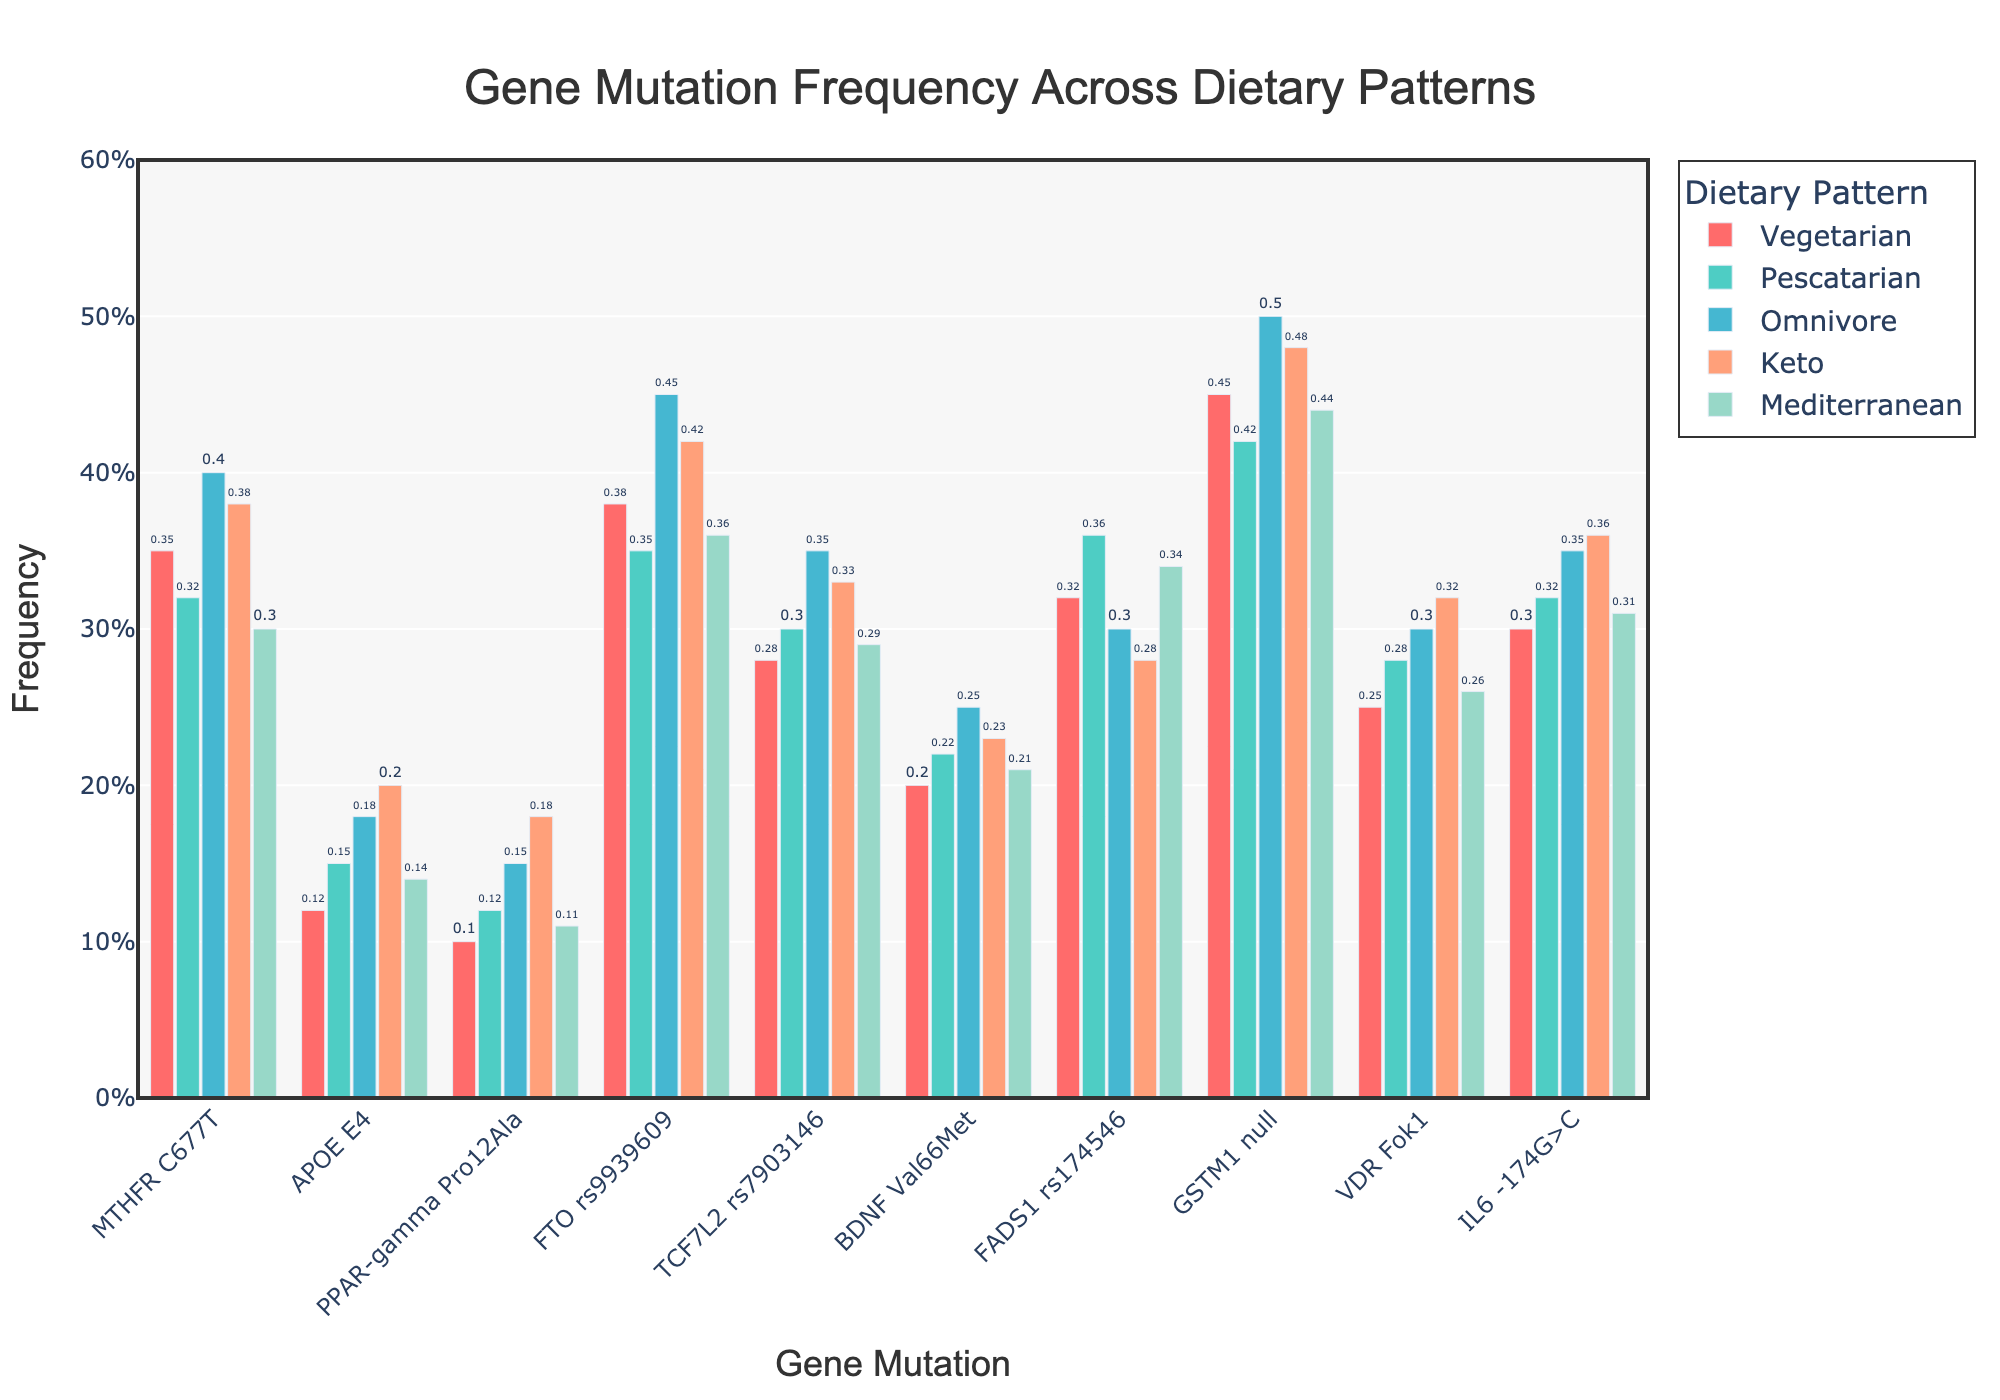Which dietary pattern has the highest frequency of the APOE E4 gene mutation? To determine this, look at the bars associated with the APOE E4 gene mutation across different dietary patterns. The highest bar corresponds to the 'keto' diet.
Answer: Keto What is the difference in frequency of the MTHFR C677T mutation between vegetarians and omnivores? Find the frequency of the MTHFR C677T mutation for both vegetarians (0.35) and omnivores (0.40) from the chart. Subtract the vegetarian frequency from the omnivore frequency to get the difference: 0.40 - 0.35 = 0.05.
Answer: 0.05 Which gene mutation has the highest frequency in the pescatarian diet? Look at the bars corresponding to each gene mutation within the pescatarian category. The 'GSTM1 null' mutation has the highest frequency, indicated by the tallest bar.
Answer: GSTM1 null What is the average frequency of the TCF7L2 rs7903146 mutation across all dietary patterns? Sum the frequencies of TCF7L2 rs7903146 mutation across all diets (0.28 + 0.30 + 0.35 + 0.33 + 0.29) = 1.55. Divide this sum by the number of dietary patterns (5): 1.55 / 5 = 0.31.
Answer: 0.31 How does the frequency of the FTO rs9939609 mutation in the keto diet compare to the Mediterranean diet? Observe the heights of the bars for the FTO rs9939609 mutation for both the keto diet (0.42) and the Mediterranean diet (0.36). The bar for the keto diet is higher than the one for the Mediterranean diet.
Answer: Higher Which dietary pattern has the lowest overall frequency for the BDNF Val66Met mutation? Examine the bars representing the BDNF Val66Met mutation across all dietary patterns. The lowest frequency bar corresponds to the 'vegetarian' diet.
Answer: Vegetarian If you sum the frequencies of the VDR Fok1 mutation in the vegetarian and pescatarian diets, what do you get? Find the frequencies of VDR Fok1 for vegetarians (0.25) and pescatarians (0.28). Add them together: 0.25 + 0.28 = 0.53.
Answer: 0.53 What is the ratio of the frequencies of the GSTM1 null mutation between the vegetarian and omnivore diets? Identify the frequencies of the GSTM1 null mutation for vegetarians (0.45) and omnivores (0.50). Calculate the ratio by dividing the vegetarian frequency by the omnivore frequency: 0.45 / 0.50 = 0.9.
Answer: 0.9 